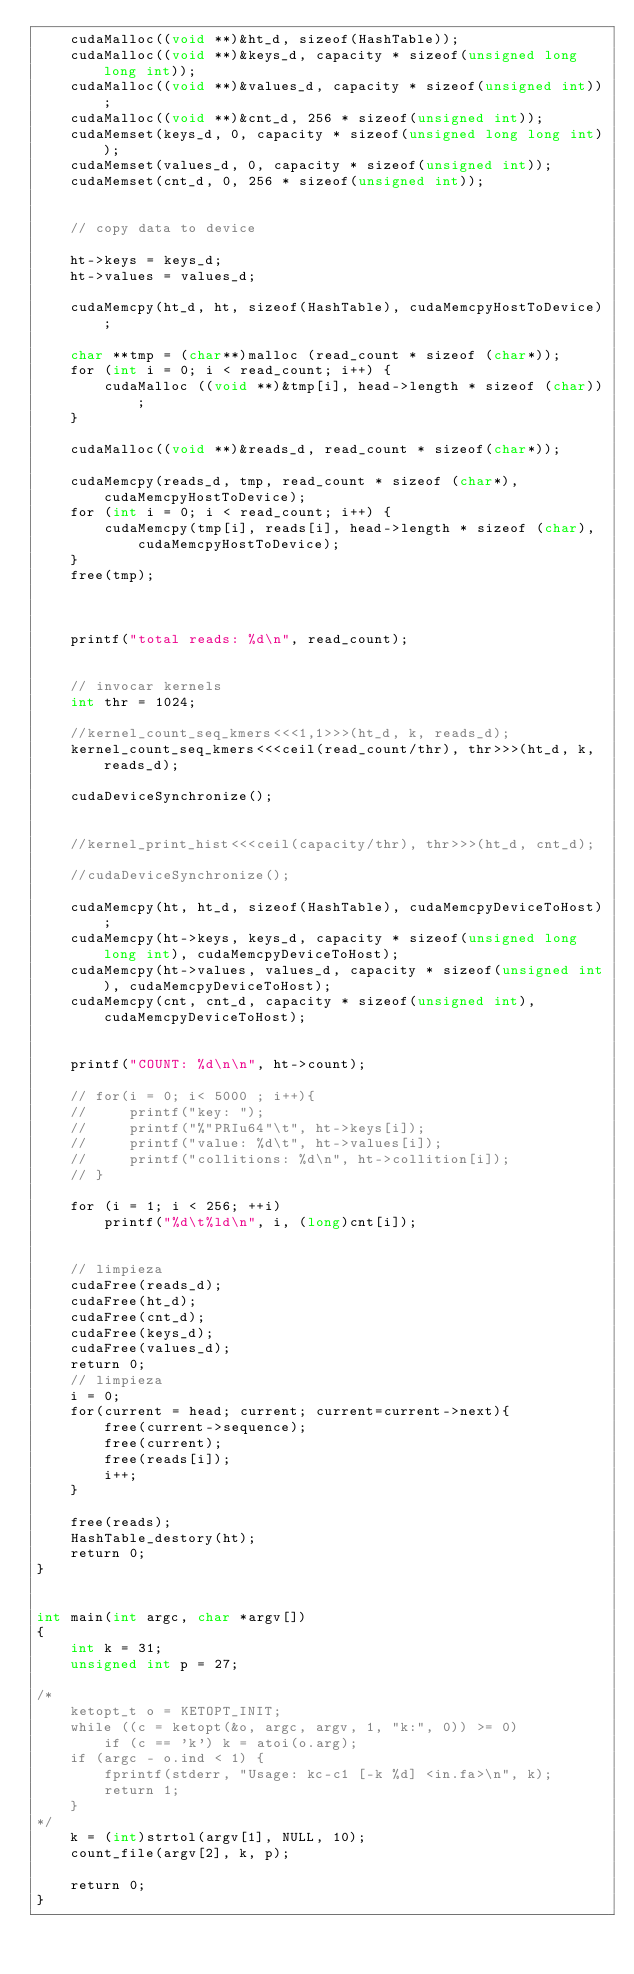<code> <loc_0><loc_0><loc_500><loc_500><_Cuda_>	cudaMalloc((void **)&ht_d, sizeof(HashTable));
   	cudaMalloc((void **)&keys_d, capacity * sizeof(unsigned long long int));
	cudaMalloc((void **)&values_d, capacity * sizeof(unsigned int));
	cudaMalloc((void **)&cnt_d, 256 * sizeof(unsigned int));
   	cudaMemset(keys_d, 0, capacity * sizeof(unsigned long long int));
	cudaMemset(values_d, 0, capacity * sizeof(unsigned int));
	cudaMemset(cnt_d, 0, 256 * sizeof(unsigned int));

    
	// copy data to device

    ht->keys = keys_d;
    ht->values = values_d;

	cudaMemcpy(ht_d, ht, sizeof(HashTable), cudaMemcpyHostToDevice);

	char **tmp = (char**)malloc (read_count * sizeof (char*));
    for (int i = 0; i < read_count; i++) {
        cudaMalloc ((void **)&tmp[i], head->length * sizeof (char));
    }

	cudaMalloc((void **)&reads_d, read_count * sizeof(char*));

    cudaMemcpy(reads_d, tmp, read_count * sizeof (char*), cudaMemcpyHostToDevice);
    for (int i = 0; i < read_count; i++) {
        cudaMemcpy(tmp[i], reads[i], head->length * sizeof (char), cudaMemcpyHostToDevice);
    }
    free(tmp);



    printf("total reads: %d\n", read_count);


    // invocar kernels
    int thr = 1024;

	//kernel_count_seq_kmers<<<1,1>>>(ht_d, k, reads_d);
	kernel_count_seq_kmers<<<ceil(read_count/thr), thr>>>(ht_d, k, reads_d);

    cudaDeviceSynchronize();


	//kernel_print_hist<<<ceil(capacity/thr), thr>>>(ht_d, cnt_d);

    //cudaDeviceSynchronize();

	cudaMemcpy(ht, ht_d, sizeof(HashTable), cudaMemcpyDeviceToHost);
	cudaMemcpy(ht->keys, keys_d, capacity * sizeof(unsigned long long int), cudaMemcpyDeviceToHost);
	cudaMemcpy(ht->values, values_d, capacity * sizeof(unsigned int), cudaMemcpyDeviceToHost);
	cudaMemcpy(cnt, cnt_d, capacity * sizeof(unsigned int), cudaMemcpyDeviceToHost);


    printf("COUNT: %d\n\n", ht->count);

    // for(i = 0; i< 5000 ; i++){
    //     printf("key: ");
    //     printf("%"PRIu64"\t", ht->keys[i]);
    //     printf("value: %d\t", ht->values[i]);
    //     printf("collitions: %d\n", ht->collition[i]);
    // }

	for (i = 1; i < 256; ++i)
		printf("%d\t%ld\n", i, (long)cnt[i]);


	// limpieza
    cudaFree(reads_d);
	cudaFree(ht_d);
	cudaFree(cnt_d);
	cudaFree(keys_d);
	cudaFree(values_d);
    return 0;
	// limpieza
    i = 0;
	for(current = head; current; current=current->next){
        free(current->sequence);
        free(current);
        free(reads[i]);
        i++;
    }

    free(reads);
	HashTable_destory(ht);
    return 0;
}


int main(int argc, char *argv[])
{
	int k = 31;
    unsigned int p = 27;

/*
	ketopt_t o = KETOPT_INIT;
	while ((c = ketopt(&o, argc, argv, 1, "k:", 0)) >= 0)
		if (c == 'k') k = atoi(o.arg);
	if (argc - o.ind < 1) {
		fprintf(stderr, "Usage: kc-c1 [-k %d] <in.fa>\n", k);
		return 1;
	}
*/
    k = (int)strtol(argv[1], NULL, 10);
	count_file(argv[2], k, p);

	return 0;
}
</code> 